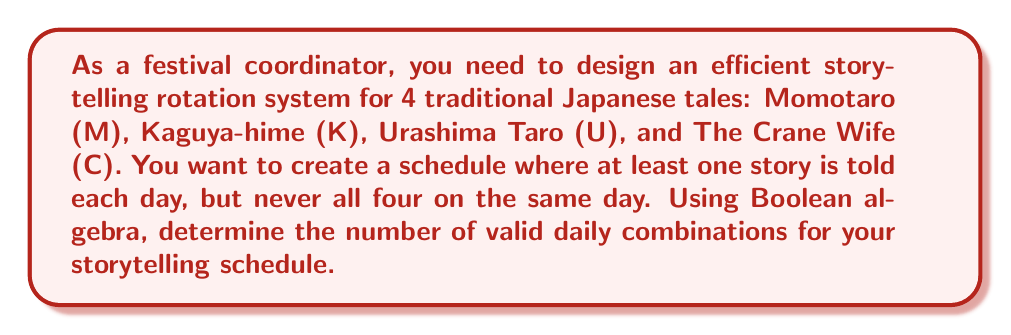Show me your answer to this math problem. Let's approach this step-by-step using Boolean algebra:

1) First, let's define our variables:
   M: Momotaro is told
   K: Kaguya-hime is told
   U: Urashima Taro is told
   C: The Crane Wife is told

2) We need to find all combinations where at least one story is told, but not all four. In Boolean terms, this can be expressed as:

   $$(M \lor K \lor U \lor C) \land \lnot(M \land K \land U \land C)$$

3) To count the number of valid combinations, we can use the principle of inclusion-exclusion:

   $$|M \lor K \lor U \lor C| - |M \land K \land U \land C|$$

4) For $|M \lor K \lor U \lor C|$, we have:
   $$2^4 - 1 = 15$$ (all possible combinations except when no story is told)

5) For $|M \land K \land U \land C|$, we have:
   $$1$$ (the case where all stories are told)

6) Therefore, the number of valid combinations is:
   $$15 - 1 = 14$$

This means there are 14 different ways to schedule the stories each day while meeting the given criteria.
Answer: 14 